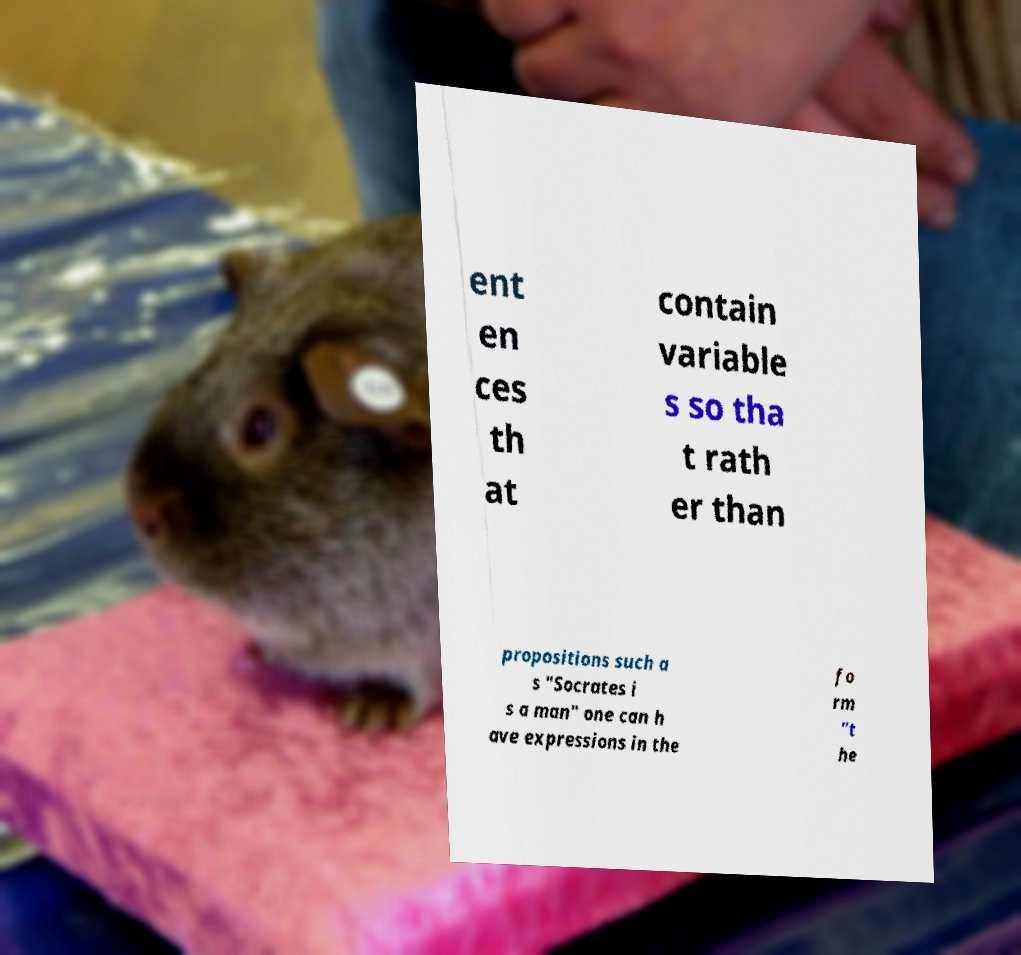Can you read and provide the text displayed in the image?This photo seems to have some interesting text. Can you extract and type it out for me? ent en ces th at contain variable s so tha t rath er than propositions such a s "Socrates i s a man" one can h ave expressions in the fo rm "t he 